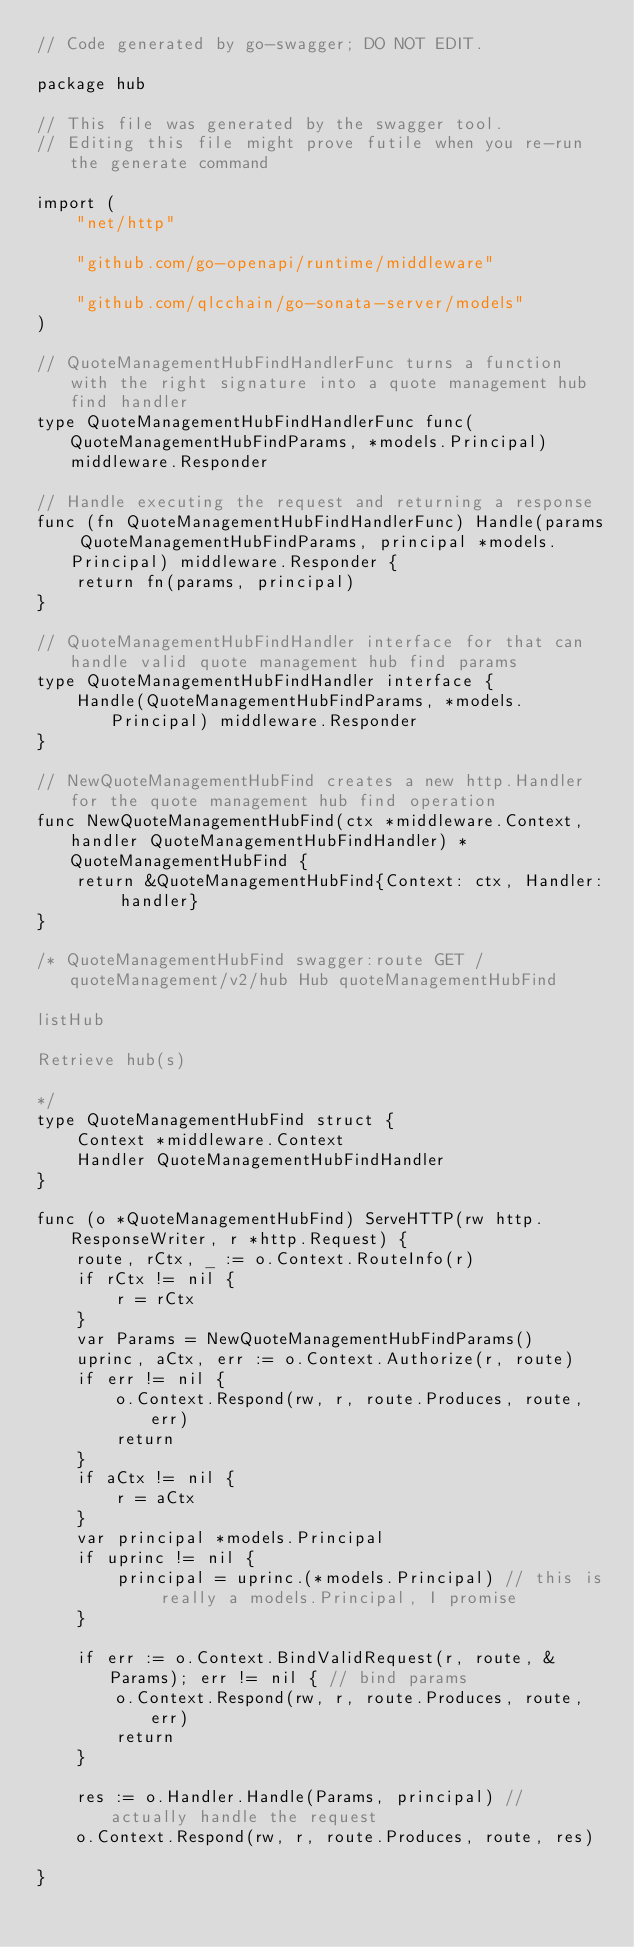<code> <loc_0><loc_0><loc_500><loc_500><_Go_>// Code generated by go-swagger; DO NOT EDIT.

package hub

// This file was generated by the swagger tool.
// Editing this file might prove futile when you re-run the generate command

import (
	"net/http"

	"github.com/go-openapi/runtime/middleware"

	"github.com/qlcchain/go-sonata-server/models"
)

// QuoteManagementHubFindHandlerFunc turns a function with the right signature into a quote management hub find handler
type QuoteManagementHubFindHandlerFunc func(QuoteManagementHubFindParams, *models.Principal) middleware.Responder

// Handle executing the request and returning a response
func (fn QuoteManagementHubFindHandlerFunc) Handle(params QuoteManagementHubFindParams, principal *models.Principal) middleware.Responder {
	return fn(params, principal)
}

// QuoteManagementHubFindHandler interface for that can handle valid quote management hub find params
type QuoteManagementHubFindHandler interface {
	Handle(QuoteManagementHubFindParams, *models.Principal) middleware.Responder
}

// NewQuoteManagementHubFind creates a new http.Handler for the quote management hub find operation
func NewQuoteManagementHubFind(ctx *middleware.Context, handler QuoteManagementHubFindHandler) *QuoteManagementHubFind {
	return &QuoteManagementHubFind{Context: ctx, Handler: handler}
}

/* QuoteManagementHubFind swagger:route GET /quoteManagement/v2/hub Hub quoteManagementHubFind

listHub

Retrieve hub(s)

*/
type QuoteManagementHubFind struct {
	Context *middleware.Context
	Handler QuoteManagementHubFindHandler
}

func (o *QuoteManagementHubFind) ServeHTTP(rw http.ResponseWriter, r *http.Request) {
	route, rCtx, _ := o.Context.RouteInfo(r)
	if rCtx != nil {
		r = rCtx
	}
	var Params = NewQuoteManagementHubFindParams()
	uprinc, aCtx, err := o.Context.Authorize(r, route)
	if err != nil {
		o.Context.Respond(rw, r, route.Produces, route, err)
		return
	}
	if aCtx != nil {
		r = aCtx
	}
	var principal *models.Principal
	if uprinc != nil {
		principal = uprinc.(*models.Principal) // this is really a models.Principal, I promise
	}

	if err := o.Context.BindValidRequest(r, route, &Params); err != nil { // bind params
		o.Context.Respond(rw, r, route.Produces, route, err)
		return
	}

	res := o.Handler.Handle(Params, principal) // actually handle the request
	o.Context.Respond(rw, r, route.Produces, route, res)

}
</code> 